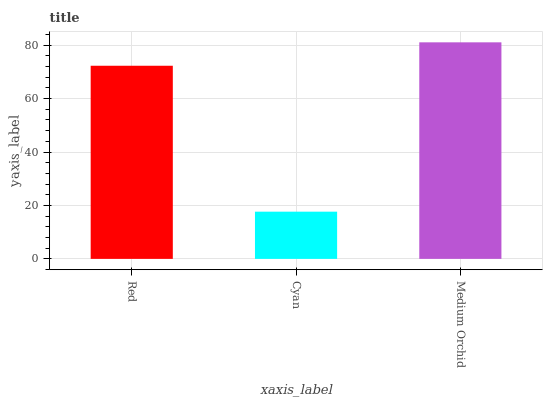Is Cyan the minimum?
Answer yes or no. Yes. Is Medium Orchid the maximum?
Answer yes or no. Yes. Is Medium Orchid the minimum?
Answer yes or no. No. Is Cyan the maximum?
Answer yes or no. No. Is Medium Orchid greater than Cyan?
Answer yes or no. Yes. Is Cyan less than Medium Orchid?
Answer yes or no. Yes. Is Cyan greater than Medium Orchid?
Answer yes or no. No. Is Medium Orchid less than Cyan?
Answer yes or no. No. Is Red the high median?
Answer yes or no. Yes. Is Red the low median?
Answer yes or no. Yes. Is Cyan the high median?
Answer yes or no. No. Is Cyan the low median?
Answer yes or no. No. 